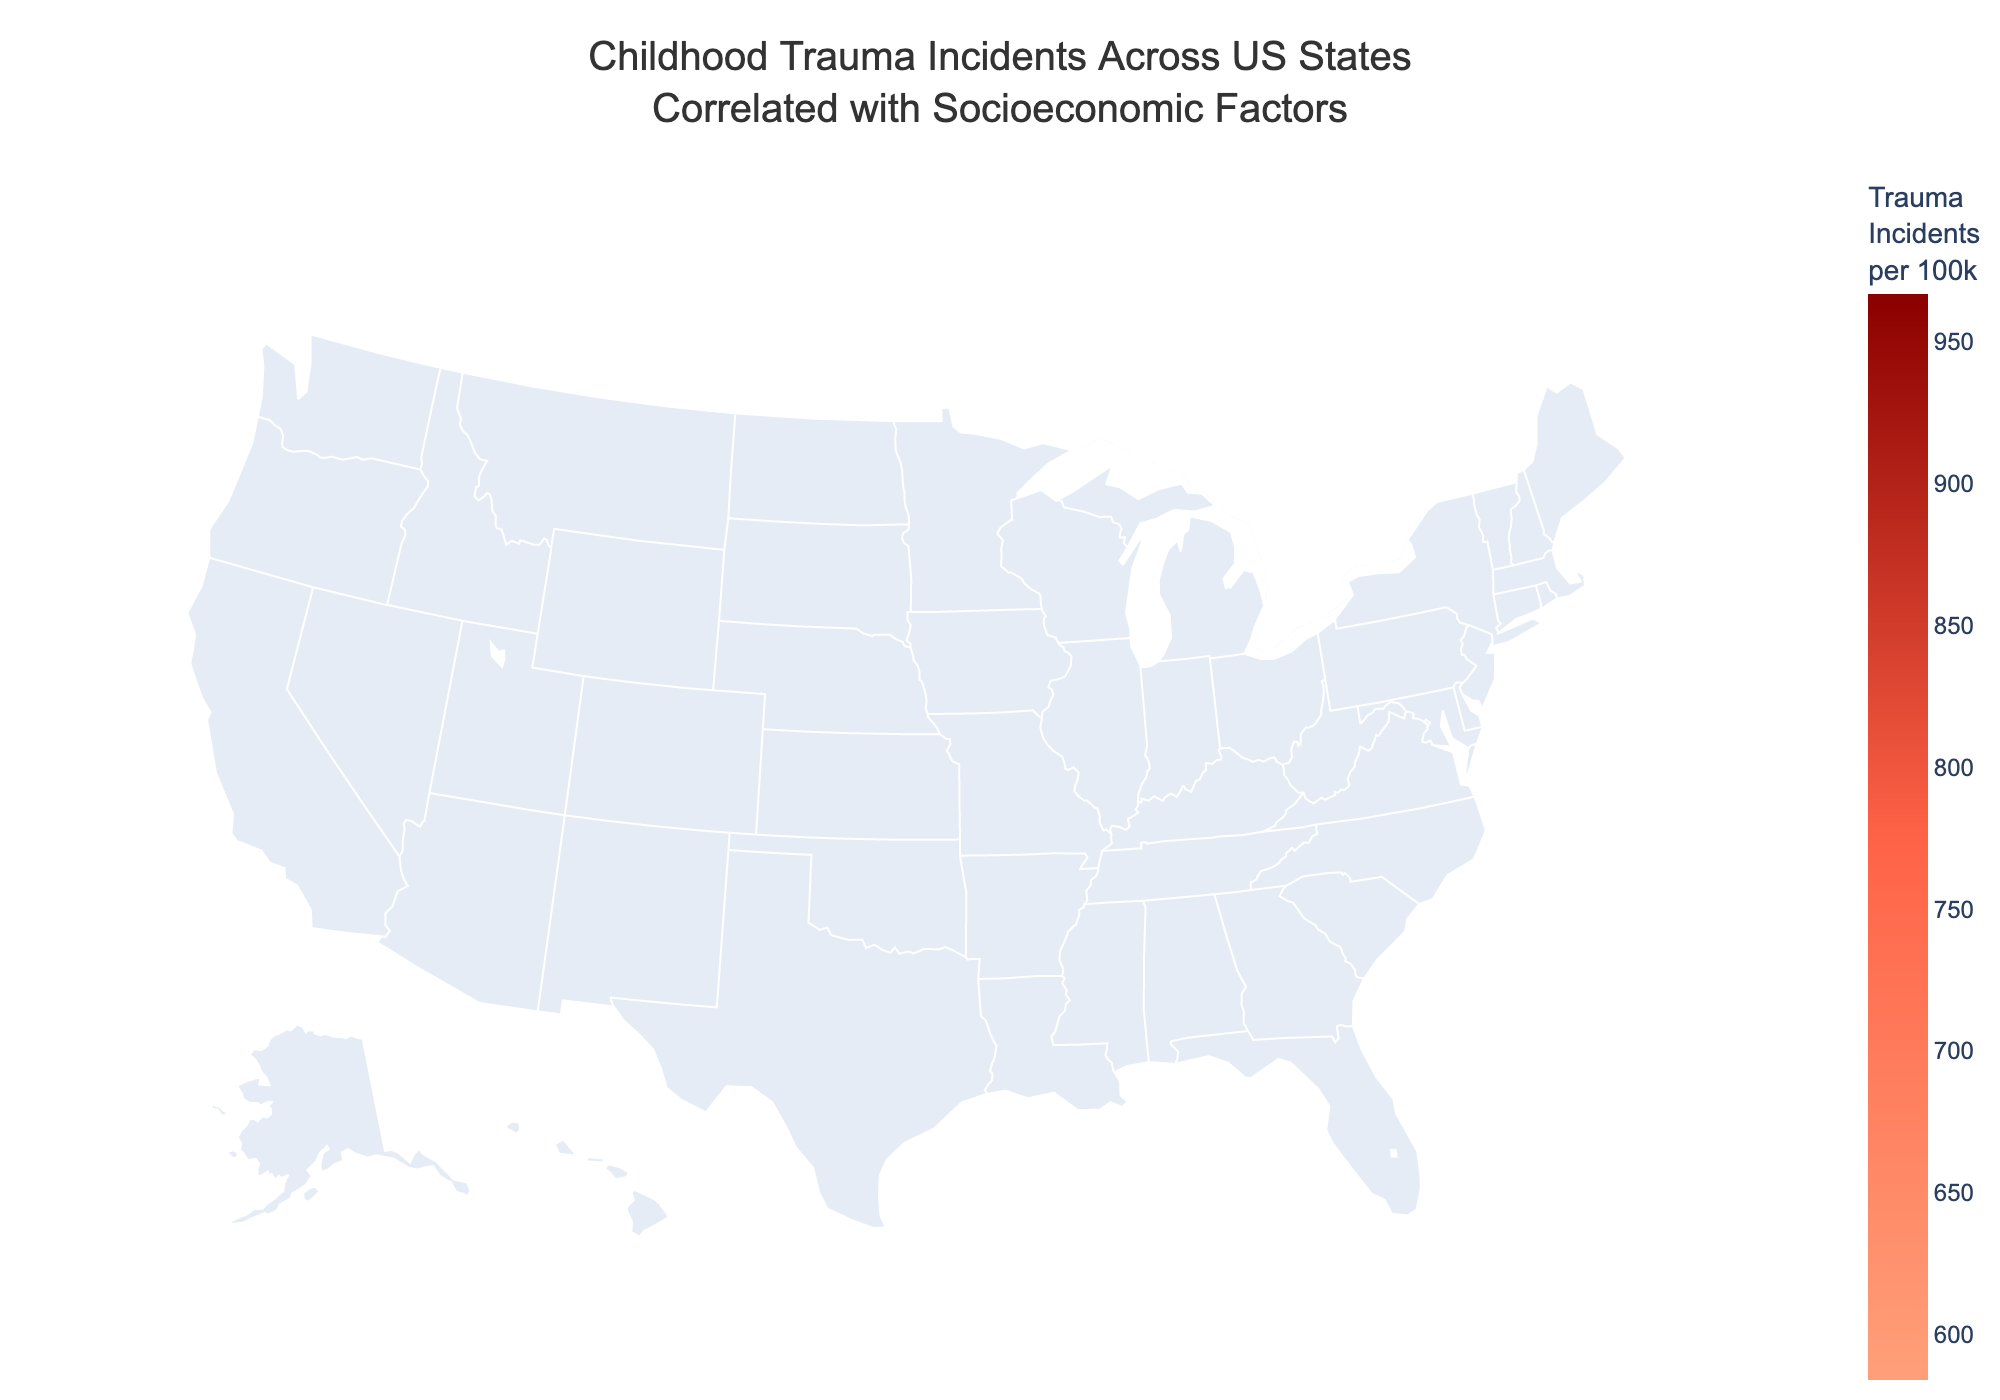Which state has the highest reported childhood trauma incidents per 100k? The plot shows childhood trauma incidents per 100k for each state, and the highest value is 967 for Tennessee.
Answer: Tennessee Which state has the lowest median household income? By looking at the hover data for each state, we find Tennessee has the lowest median household income of $54833.
Answer: Tennessee What is the title of the figure? The title of the figure is displayed at the top of the plot: "Childhood Trauma Incidents Across US States Correlated with Socioeconomic Factors.”
Answer: Childhood Trauma Incidents Across US States Correlated with Socioeconomic Factors Which state has a higher unemployment rate, California or New Jersey? The hover data provides the unemployment rates for each state. California has 4.2%, while New Jersey has 3.9%, meaning California has a higher unemployment rate.
Answer: California What is the poverty rate for the state with the highest trauma incidents? Tennessee has the highest trauma incidents, which is 967. The hover data shows Tennessee's poverty rate is 13.9%.
Answer: 13.9% Compare the trauma incidents per 100k between Ohio and Florida. Which state has more incidents? By examining the figures, Ohio has 921 trauma incidents per 100k, while Florida has 892. Thus, Ohio has more incidents.
Answer: Ohio What are the socioeconomic factors correlated with the trauma incidents according to the plot? The hover data in the plot lists the socioeconomic factors that include: Median Household Income, Poverty Rate (%), and Unemployment Rate (%).
Answer: Median Household Income, Poverty Rate (%), Unemployment Rate (%) Which states have a trauma incidents per 100k less than 700? From the plot, the states with less than 700 incidents per 100k are New Jersey, Massachusetts, Maryland, Washington, and Illinois.
Answer: New Jersey, Massachusetts, Maryland, Washington, Illinois Which state has a higher median household income, Texas or Virginia? Looking at the hover data, Texas has a median household income of $61874 and Virginia has $76456, indicating Virginia has a higher median household income.
Answer: Virginia What is the range of trauma incidents per 100k across the states shown? To find the range, subtract the minimum value of trauma incidents per 100k (New Jersey, 602) from the maximum value (Tennessee, 967). The range is 967 - 602 = 365.
Answer: 365 